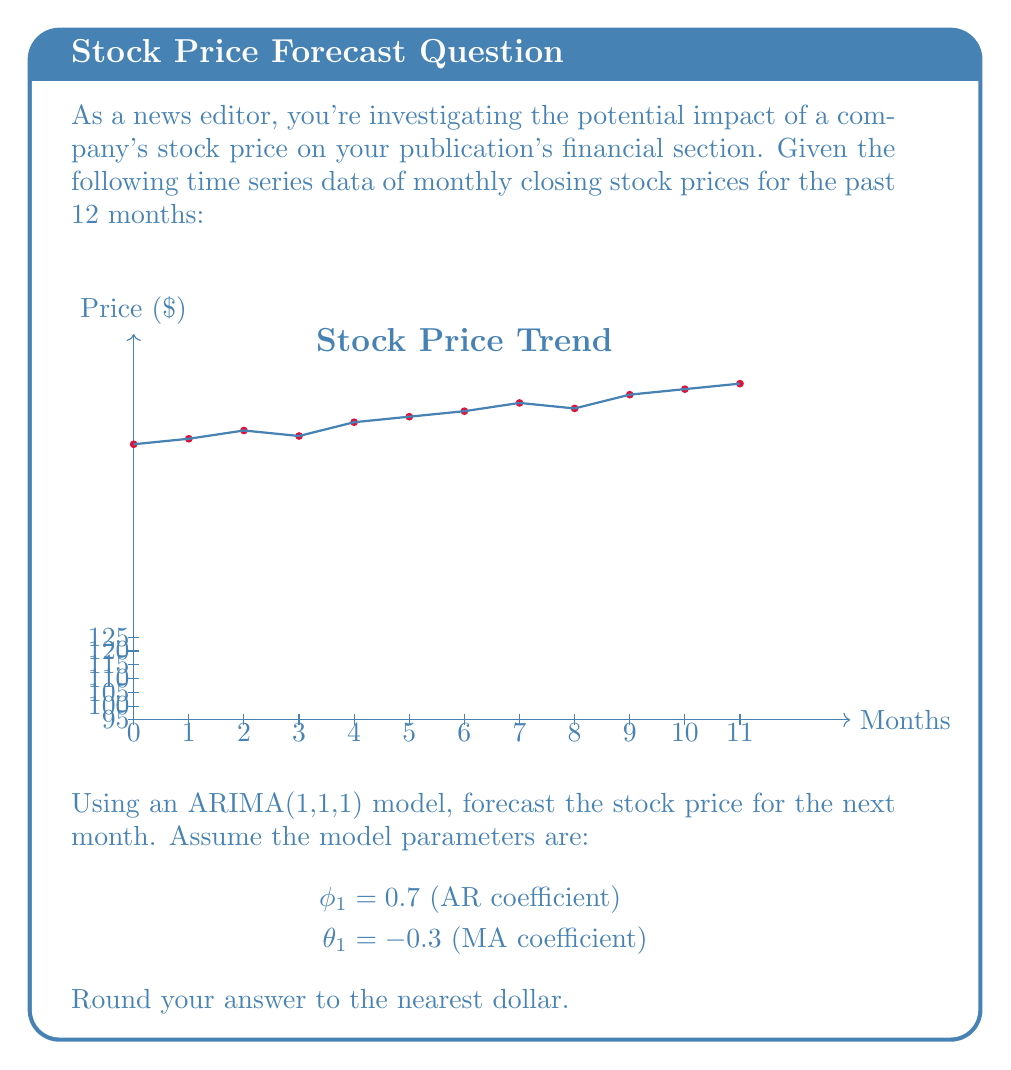What is the answer to this math problem? To forecast the stock price using an ARIMA(1,1,1) model, we need to follow these steps:

1) First, we need to difference the series once to make it stationary. Let $y_t$ be the differenced series:

   $y_t = x_t - x_{t-1}$

   The last few values of $y_t$ are:
   $y_{11} = 122 - 120 = 2$
   $y_{10} = 120 - 118 = 2$
   $y_9 = 118 - 113 = 5$

2) The ARIMA(1,1,1) model for the differenced series is:

   $y_t = c + \phi_1 y_{t-1} + \epsilon_t - \theta_1 \epsilon_{t-1}$

   Where $c$ is a constant (which we'll assume to be 0 for simplicity), $\epsilon_t$ is the error term.

3) To forecast $y_{12}$, we use:

   $\hat{y}_{12} = \phi_1 y_{11} - \theta_1 \epsilon_{11}$

   We don't know $\epsilon_{11}$, but we can estimate it as the difference between the observed and predicted value for $y_{11}$:

   $\epsilon_{11} \approx y_{11} - \hat{y}_{11} = y_{11} - (\phi_1 y_{10} - \theta_1 \epsilon_{10})$

   $\epsilon_{11} \approx 2 - (0.7 * 2 - (-0.3) * (2 - 0.7 * 5)) \approx -0.31$

4) Now we can calculate $\hat{y}_{12}$:

   $\hat{y}_{12} = 0.7 * 2 - (-0.3) * (-0.31) \approx 1.49$

5) To get the forecast for $x_{12}$, we need to "undifference":

   $\hat{x}_{12} = x_{11} + \hat{y}_{12} = 122 + 1.49 = 123.49$

6) Rounding to the nearest dollar gives us 123.
Answer: $123 